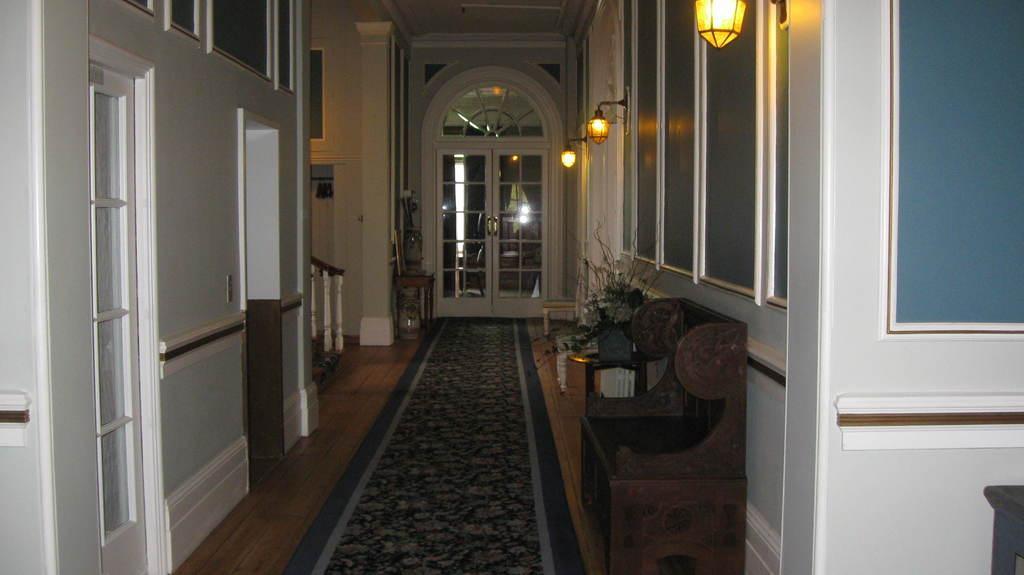Please provide a concise description of this image. In this picture I can see inner view of a building and I can see few lights and I can see a wooden chair and a carpet on the floor and I can see a glass door and looks like a table at the bottom right corner of the picture. 